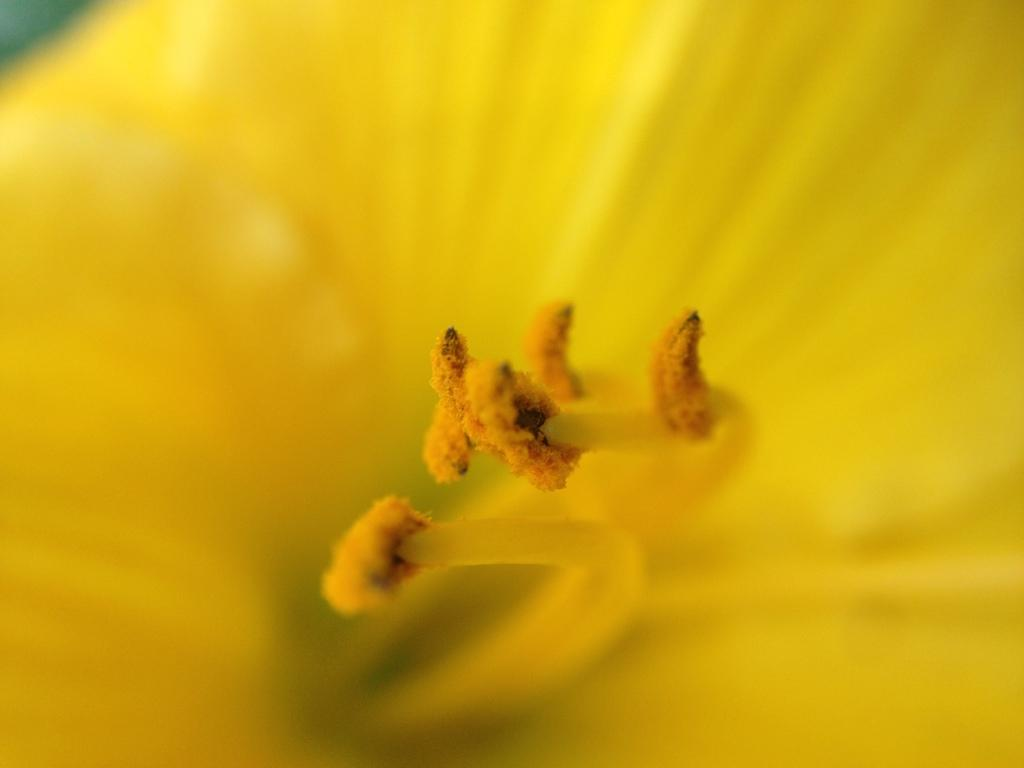What type of flower can be seen in the image? There is a yellow flower in the image. What stage of growth are some of the flowers in the image? There are buds in the image, which suggests they are in an early stage of growth. What type of cave can be seen in the image? There is no cave present in the image; it features a yellow flower and buds. Who is the representative of the flowers in the image? There is no representative present in the image; it simply shows a yellow flower and buds. 